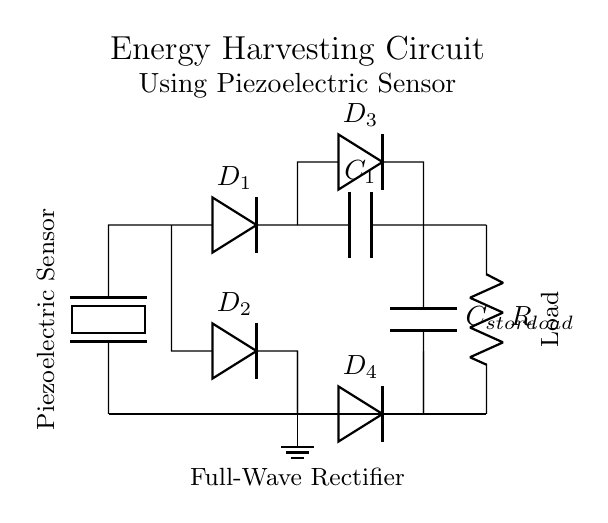What type of sensor is used in this circuit? The circuit prominently features a piezoelectric sensor, which is designed to convert mechanical stress, such as vibrations or movement, into electrical energy. This can be observed at the left side of the circuit, where the sensor is explicitly labeled.
Answer: Piezoelectric sensor What is the function of the diodes in this circuit? The diodes in the circuit (D1, D2, D3, and D4) function as rectifiers, ensuring that the current produced by the piezoelectric sensor flows in a single direction. This is critical for converting the alternating current into direct current suitable for charging the capacitor and powering the load. Their arrangement indicates a full-wave rectification process.
Answer: Rectification What is the purpose of the capacitor labeled C_store? The capacitor C_store acts as an energy storage element. It collects and holds the electric charge generated by the piezoelectric sensor during its operation, providing a stable power supply to the load when needed. It smooths out fluctuations in voltage, ensuring a steady output.
Answer: Energy storage How many diodes are used in this circuit? The circuit features a total of four diodes, which are labeled as D1, D2, D3, and D4. They are combined to form both the rectification path and a safety mechanism to prevent backflow of current.
Answer: Four What type of load is connected to the circuit? The load indicated in the circuit is a resistor, labeled as R_load. Resistors are commonly used in circuits to consume power, convert the electrical energy into heat, and represent various devices or components that require power.
Answer: Resistor Why is a full-wave rectifier used in this circuit? A full-wave rectifier is utilized here to maximize the energy harvesting efficiency from the piezoelectric sensor. It converts both halves of the AC signal generated from the sensor into DC, ensuring that more energy is utilized compared to a half-wave rectifier, which would only utilize half the signal. The use of four diodes, as shown, facilitates this process efficiently.
Answer: Maximize energy harvesting 